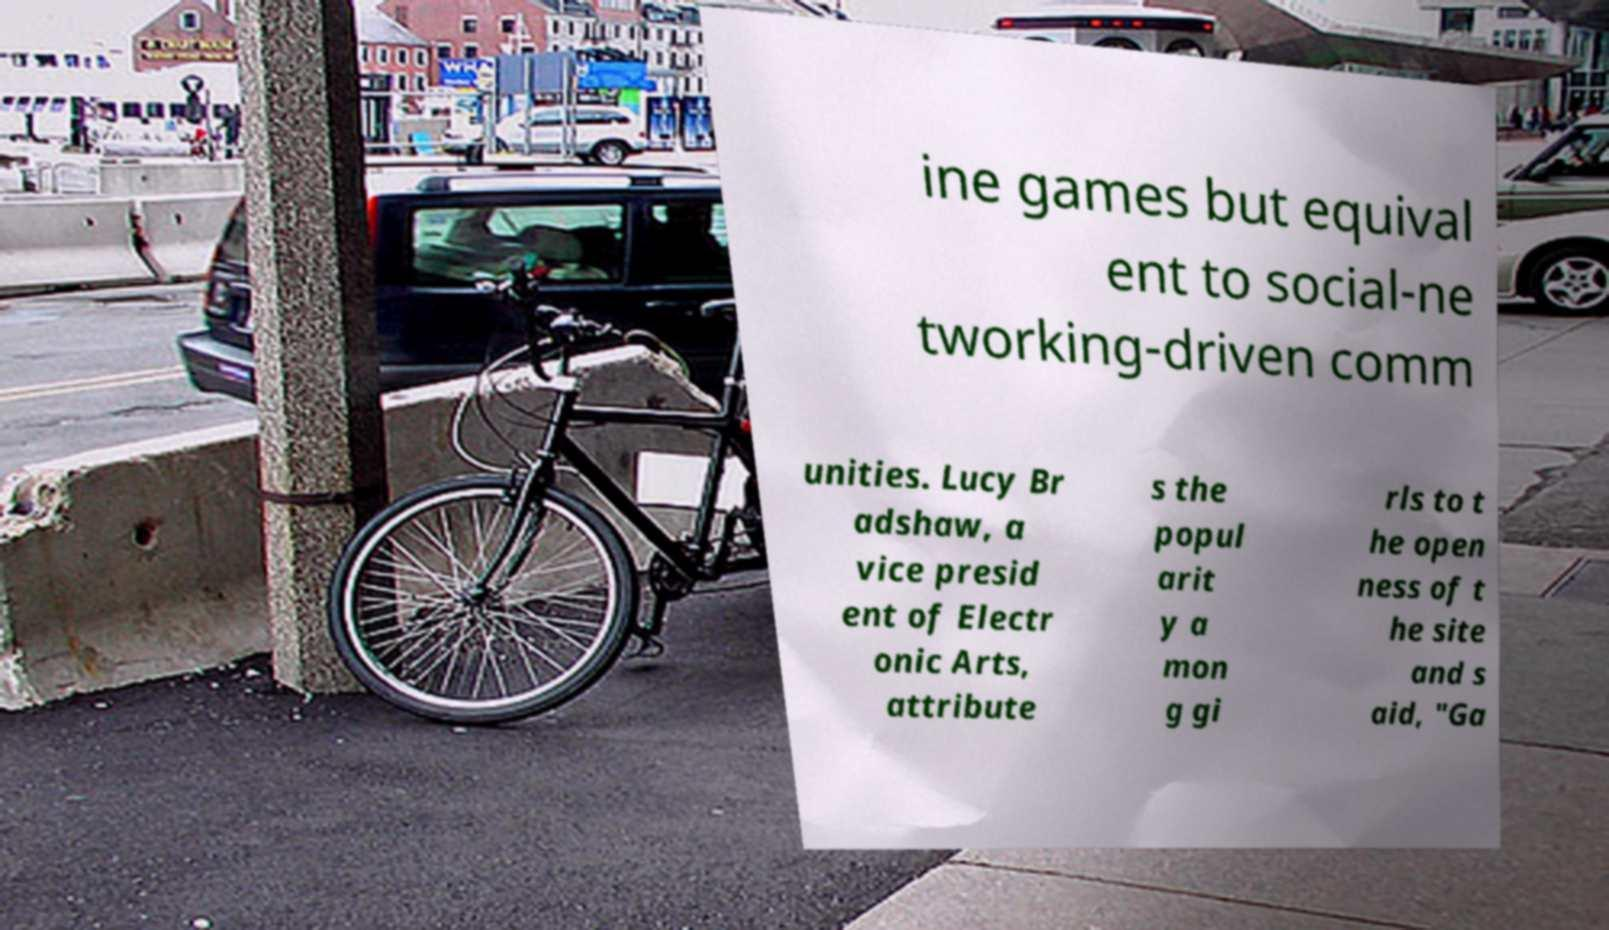Please identify and transcribe the text found in this image. ine games but equival ent to social-ne tworking-driven comm unities. Lucy Br adshaw, a vice presid ent of Electr onic Arts, attribute s the popul arit y a mon g gi rls to t he open ness of t he site and s aid, "Ga 